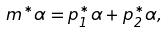Convert formula to latex. <formula><loc_0><loc_0><loc_500><loc_500>m ^ { * } \alpha = p _ { 1 } ^ { * } \alpha + p _ { 2 } ^ { * } \alpha ,</formula> 